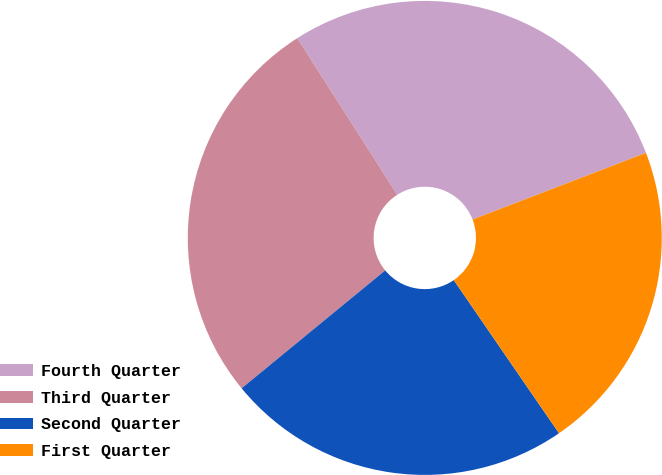Convert chart to OTSL. <chart><loc_0><loc_0><loc_500><loc_500><pie_chart><fcel>Fourth Quarter<fcel>Third Quarter<fcel>Second Quarter<fcel>First Quarter<nl><fcel>28.2%<fcel>26.9%<fcel>23.64%<fcel>21.26%<nl></chart> 